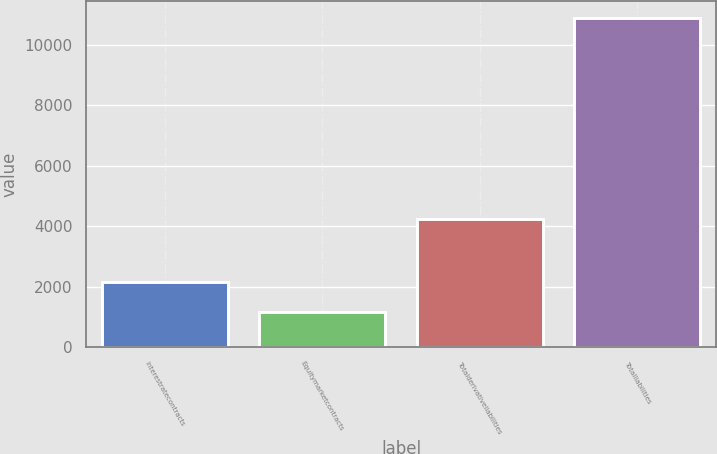<chart> <loc_0><loc_0><loc_500><loc_500><bar_chart><fcel>Interestratecontracts<fcel>Equitymarketcontracts<fcel>Totalderivativeliabilities<fcel>Totalliabilities<nl><fcel>2145.8<fcel>1174<fcel>4245<fcel>10892<nl></chart> 